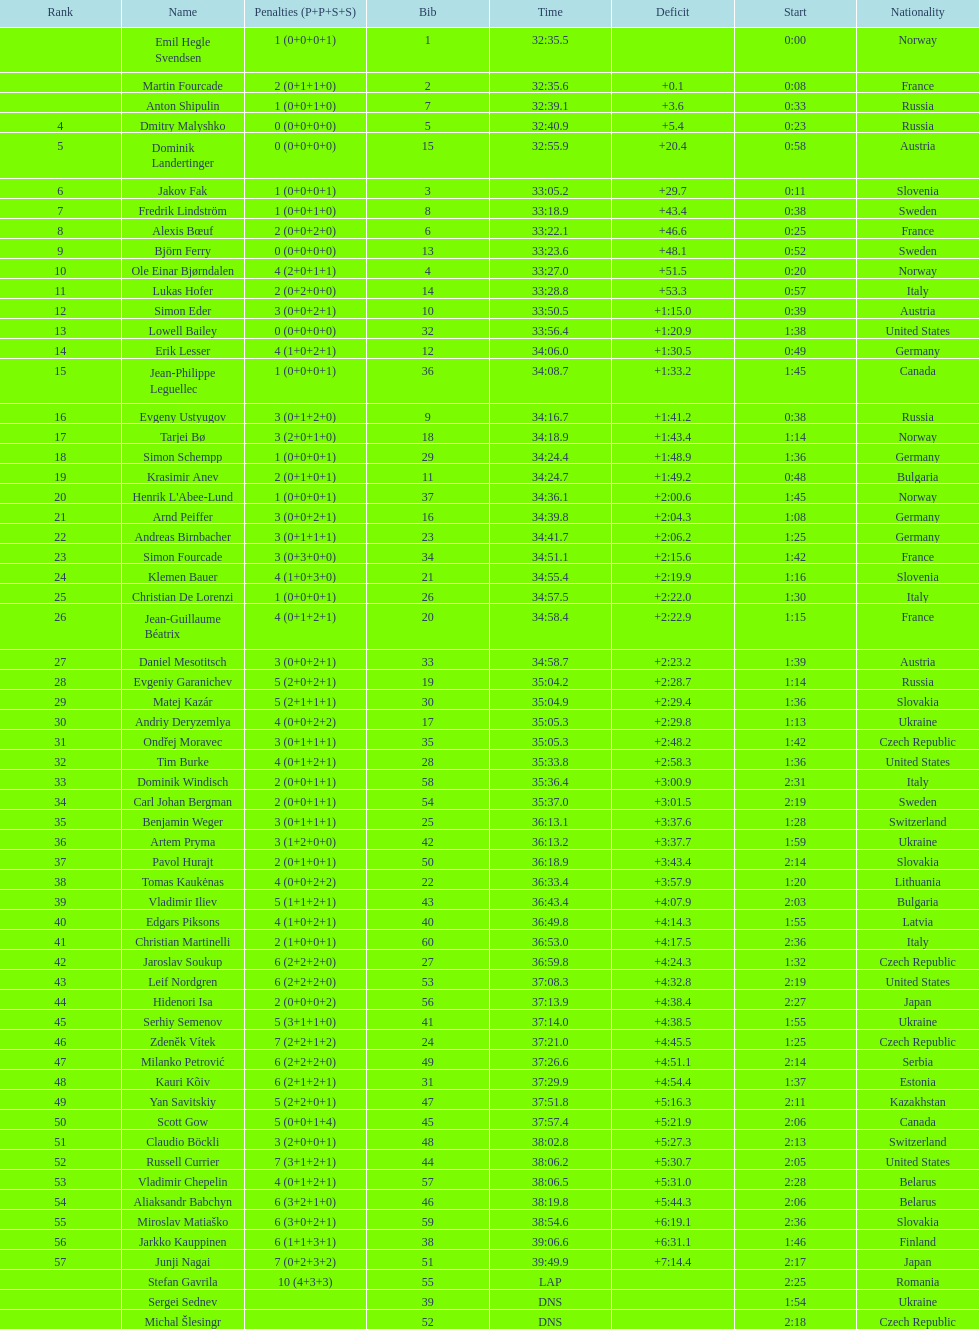How many participants had a finishing time of at least 35:00? 30. 